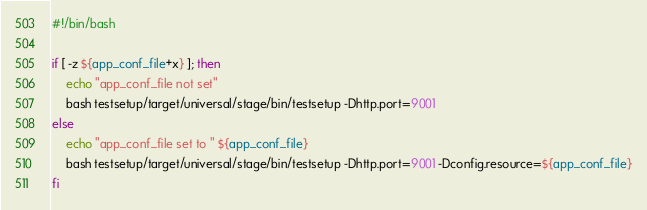<code> <loc_0><loc_0><loc_500><loc_500><_Bash_>#!/bin/bash

if [ -z ${app_conf_file+x} ]; then
    echo "app_conf_file not set"
    bash testsetup/target/universal/stage/bin/testsetup -Dhttp.port=9001
else
    echo "app_conf_file set to " ${app_conf_file}
    bash testsetup/target/universal/stage/bin/testsetup -Dhttp.port=9001 -Dconfig.resource=${app_conf_file}
fi
</code> 